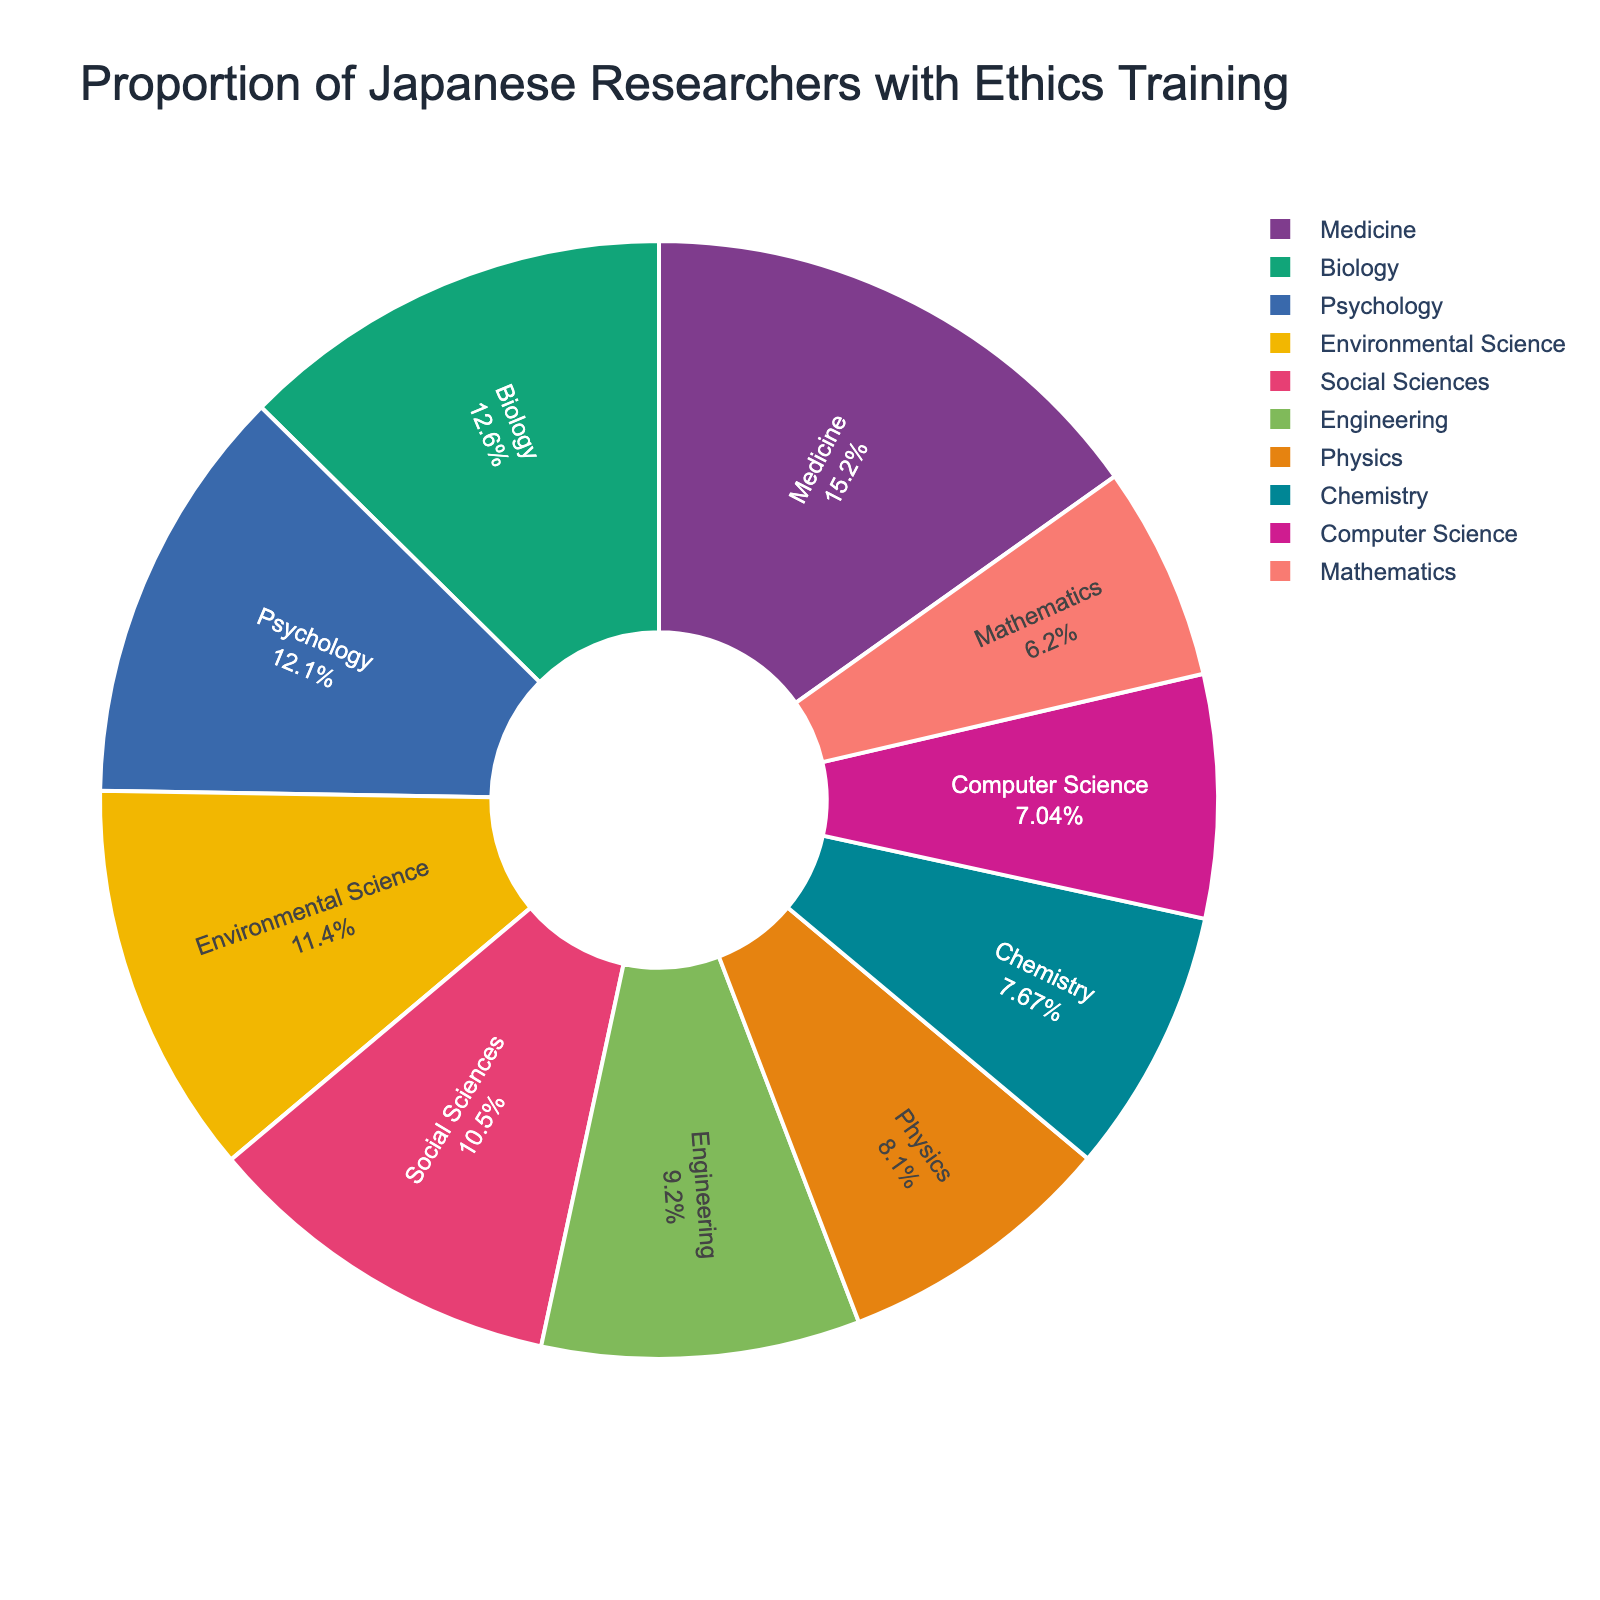Which field has the highest proportion of researchers with ethics training? The fields are sorted by percentage in descending order, and the one at the top has the highest proportion.
Answer: Medicine What is the difference in the proportion of researchers with ethics training between Psychology and Engineering? Look at the percentages for Psychology (62.8%) and Engineering (47.6%). Subtract the smaller from the larger: 62.8% - 47.6% = 15.2%.
Answer: 15.2% Which fields have a proportion of researchers with ethics training greater than 50%? Identify all fields in the chart with percentages above 50%: Medicine, Biology, Psychology, Social Sciences, and Environmental Science.
Answer: Medicine, Biology, Psychology, Social Sciences, Environmental Science How does the proportion of researchers with ethics training in Computer Science compare to that in Chemistry? Look at the percentages for Computer Science (36.4%) and Chemistry (39.7%). Compare them and see that Chemistry has a higher proportion.
Answer: Chemistry What is the total proportion of researchers with ethics training in Social Sciences and Environmental Science? Add the percentages: Social Sciences (54.3%) + Environmental Science (58.9%) = 113.2%.
Answer: 113.2% Which field has the smallest proportion of researchers with ethics training, and what is the percentage? The fields are sorted by percentage, and the one at the bottom has the smallest proportion.
Answer: Mathematics, 32.1% What is the average proportion of researchers with ethics training across all fields? Add up all the percentages and divide by the number of fields: (78.5 + 65.2 + 62.8 + 54.3 + 47.6 + 41.9 + 39.7 + 36.4 + 32.1 + 58.9) / 10 = 51.74%.
Answer: 51.74% Are there more fields with a proportion of researchers with ethics training above or below 50%? Count the number of fields above 50% (5 fields) and those below 50% (5 fields).
Answer: Equal Which field has a proportion of ethics training closest to the overall average proportion across all fields? Calculate the overall average as 51.74%. The field with the closest percentage is Social Sciences at 54.3%, which is closest to the average.
Answer: Social Sciences What is the combined proportion of researchers with ethics training in Physics, Chemistry, and Computer Science? Add the percentages for Physics (41.9%), Chemistry (39.7%), and Computer Science (36.4%): 41.9% + 39.7% + 36.4% = 118%.
Answer: 118% 